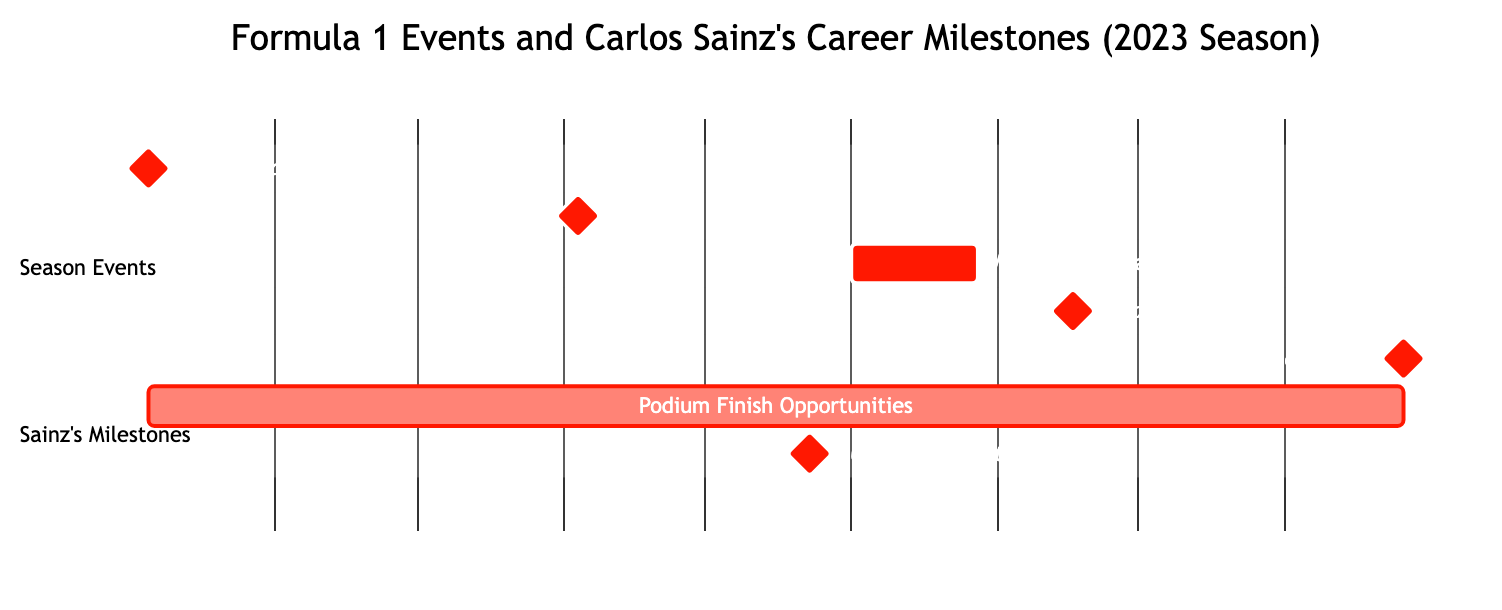What is the date of the first Grand Prix in the schedule? The first Grand Prix is listed as the "Season Start," and the date specified in the diagram is "2023-03-05."
Answer: 2023-03-05 Which event marks Carlos Sainz's home race? The diagram indicates that the "Spanish Grand Prix" is Carlos Sainz's home race, occurring on "2023-06-04."
Answer: Spanish Grand Prix How many milestones are associated with Carlos Sainz's schedule? By reviewing the milestones in the diagram, there are a total of three milestones listed: Podium Finish Opportunities, 100th Race Start, and a milestone for the events, which does not count here since the count is specific to Sainz.
Answer: 2 What is the duration of the mid-season break? The mid-season break occurs between "2023-08-01" and "2023-08-28," which can be calculated as lasting for 28 days, thus determining the duration directly from the start and end dates provided in the diagram.
Answer: 28 days When is Carlos Sainz's 100th race start? The specific milestone for Carlos Sainz's 100th race start is clearly mentioned in the diagram as taking place on "2023-07-23."
Answer: 2023-07-23 Which event happens just before the home stretch finale? The event occurring just before the home stretch (Finale in Abu Dhabi on "2023-11-26") is the "Flyaway Races," specifically the "Singapore Grand Prix," on "2023-09-17," which maintains a logical sequence leading to the season finale.
Answer: Flyaway Races How long is the opportunity for podium finishes indicated in the schedule? The opportunity for podium finishes starts from "2023-03-05" (the first Grand Prix) and lasts until the finale on "2023-11-26." This means podium opportunities span across nearly the entire season, thus representing a longer continuous timeframe.
Answer: 8 months What is the primary color used in the Gantt chart styling? The styling section of the diagram indicates that the primary color specified is "#FF1801," which is shown in the visual representation of the chart.
Answer: #FF1801 Which event corresponds with the mandatory summer break? The "Mid-Season Break" is indicated in the diagram as the event that corresponds with the mandatory summer break for all teams, occurring between the specified dates of "2023-08-01" to "2023-08-28."
Answer: Mid-Season Break 